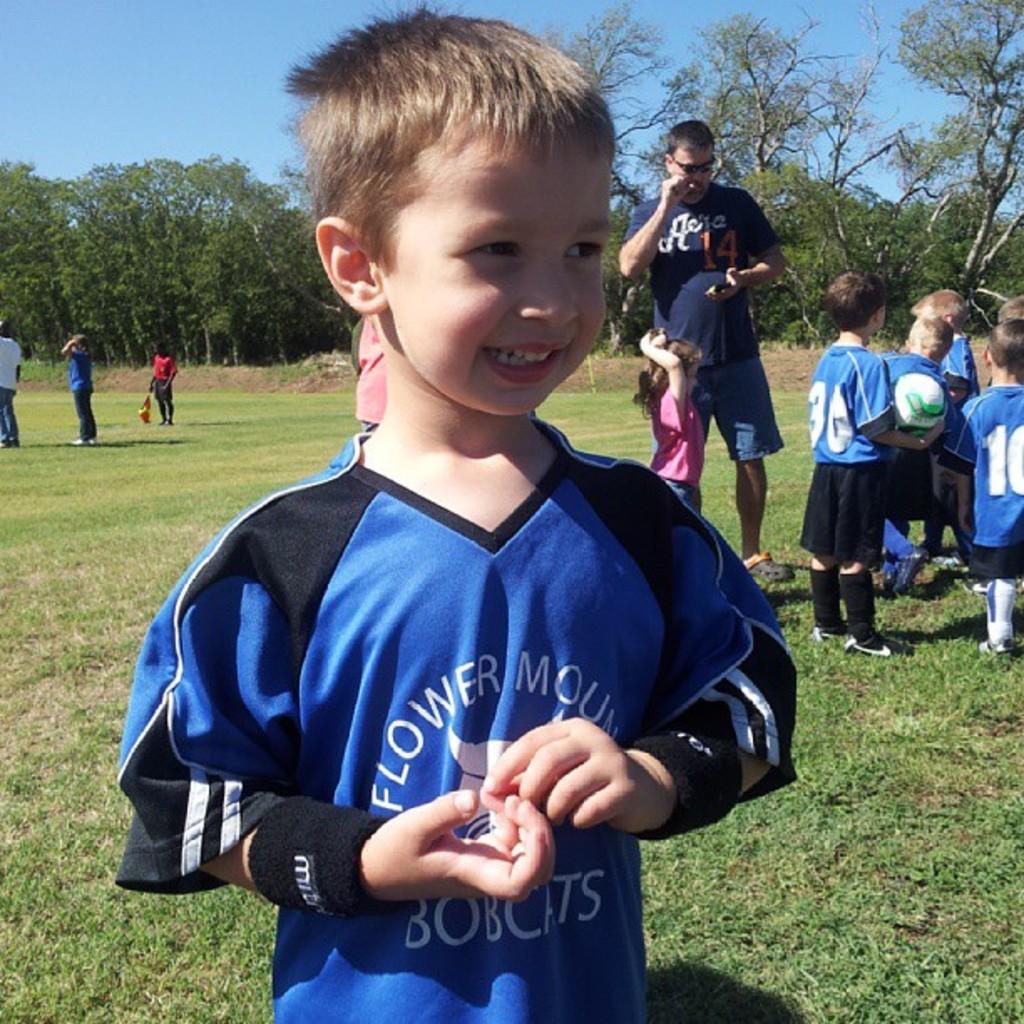Could you give a brief overview of what you see in this image? In this picture there is a boy who is wearing blue t-shirt. He is smiling. On the right we can see the group of children wearing the same dress. This boy is holding a football. Beside him this is a girl who is standing near to the man. On the left we can see the group of persons were standing on the ground. In the background we can see many trees. At the top there is a sky. 